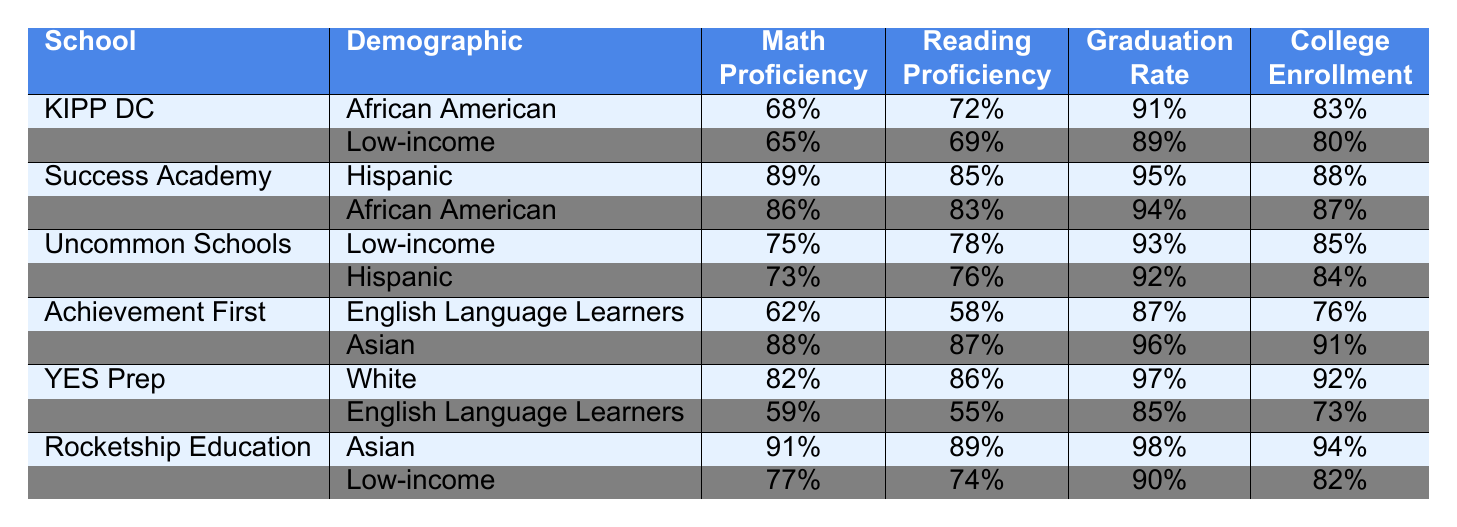What is the math proficiency percentage for African American students at KIPP DC? The table states that the math proficiency for African American students at KIPP DC is 68%.
Answer: 68% Which school has the highest reading proficiency for Hispanic students? Success Academy has the highest reading proficiency for Hispanic students at 85%.
Answer: Success Academy Is the college enrollment rate for White students at YES Prep higher than that for Low-income students at KIPP DC? The college enrollment rate for White students at YES Prep is 92%, while it is 80% for Low-income students at KIPP DC. Therefore, YES Prep has a higher rate.
Answer: Yes What is the average math proficiency for Asian students across Achievement First and Rocketship Education? For Asian students, Achievement First has 88% math proficiency and Rocketship Education has 91%. The average is (88 + 91) / 2 = 89.5%.
Answer: 89.5% Do English Language Learners at Achievement First have higher graduation rates than those at YES Prep? English Language Learners at Achievement First have a graduation rate of 87%, while those at YES Prep have a rate of 85%. Therefore, Achievement First is higher.
Answer: Yes Which demographic group has the lowest reading proficiency at Achievement First? At Achievement First, English Language Learners have the lowest reading proficiency at 58%.
Answer: English Language Learners What is the difference in graduation rates between Uncommon Schools' Low-income students and Success Academy's African American students? Uncommon Schools' Low-income students have a graduation rate of 93%, while Success Academy's African American students have a rate of 94%. The difference is 94 - 93 = 1%.
Answer: 1% Which school has the lowest math proficiency for Low-income students? KIPP DC has the lowest math proficiency for Low-income students at 65%.
Answer: KIPP DC What is the total college enrollment percentage for African American students across KIPP DC and Success Academy? KIPP DC has 83% and Success Academy has 87% college enrollment for African American students. The total is 83 + 87 = 170%.
Answer: 170% Are there any charter schools where English Language Learners have higher reading proficiency than African American students? Yes, at Achievement First, English Language Learners have a reading proficiency of 58% compared to 83% for African American students at Success Academy. Thus, this is false.
Answer: No Which demographic group has the highest college enrollment rate at Rocketship Education? The Asian demographic group at Rocketship Education has the highest college enrollment rate at 94%.
Answer: Asian 